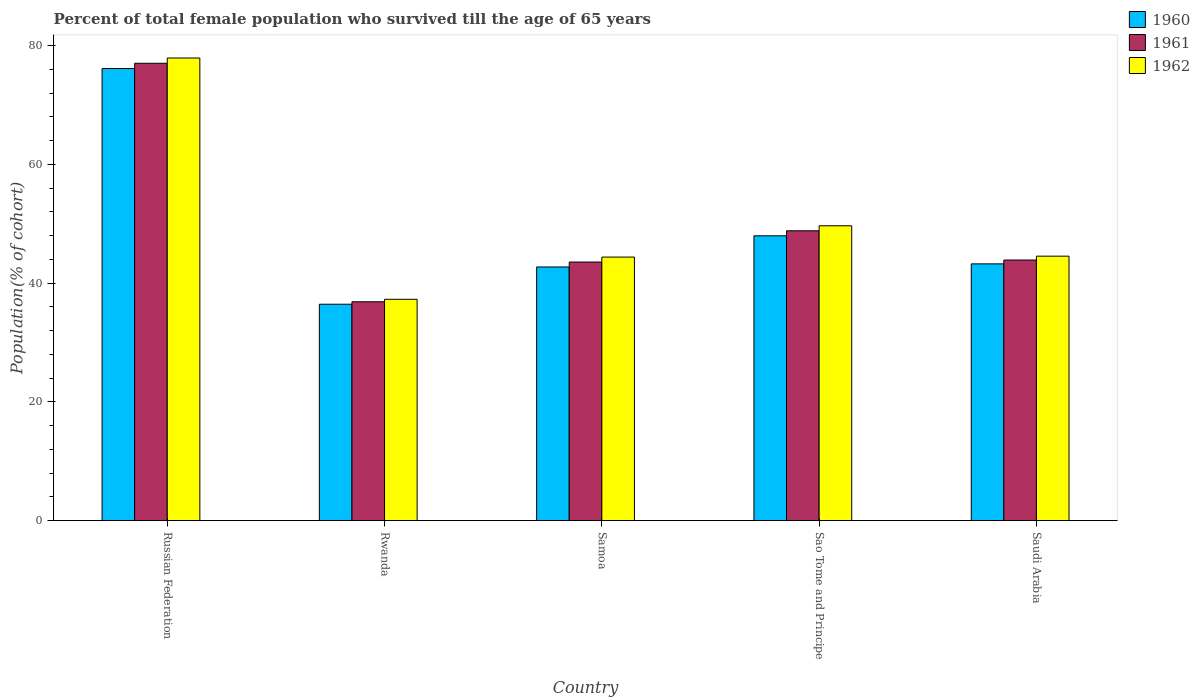Are the number of bars on each tick of the X-axis equal?
Make the answer very short. Yes. How many bars are there on the 4th tick from the right?
Offer a very short reply. 3. What is the label of the 5th group of bars from the left?
Make the answer very short. Saudi Arabia. What is the percentage of total female population who survived till the age of 65 years in 1961 in Russian Federation?
Your answer should be compact. 77.03. Across all countries, what is the maximum percentage of total female population who survived till the age of 65 years in 1961?
Provide a succinct answer. 77.03. Across all countries, what is the minimum percentage of total female population who survived till the age of 65 years in 1961?
Provide a succinct answer. 36.86. In which country was the percentage of total female population who survived till the age of 65 years in 1962 maximum?
Keep it short and to the point. Russian Federation. In which country was the percentage of total female population who survived till the age of 65 years in 1962 minimum?
Your answer should be compact. Rwanda. What is the total percentage of total female population who survived till the age of 65 years in 1962 in the graph?
Ensure brevity in your answer.  253.78. What is the difference between the percentage of total female population who survived till the age of 65 years in 1960 in Russian Federation and that in Rwanda?
Offer a very short reply. 39.7. What is the difference between the percentage of total female population who survived till the age of 65 years in 1962 in Saudi Arabia and the percentage of total female population who survived till the age of 65 years in 1960 in Russian Federation?
Offer a very short reply. -31.61. What is the average percentage of total female population who survived till the age of 65 years in 1962 per country?
Provide a short and direct response. 50.76. What is the difference between the percentage of total female population who survived till the age of 65 years of/in 1961 and percentage of total female population who survived till the age of 65 years of/in 1962 in Samoa?
Keep it short and to the point. -0.83. What is the ratio of the percentage of total female population who survived till the age of 65 years in 1960 in Russian Federation to that in Samoa?
Your response must be concise. 1.78. Is the percentage of total female population who survived till the age of 65 years in 1960 in Russian Federation less than that in Sao Tome and Principe?
Provide a succinct answer. No. Is the difference between the percentage of total female population who survived till the age of 65 years in 1961 in Russian Federation and Samoa greater than the difference between the percentage of total female population who survived till the age of 65 years in 1962 in Russian Federation and Samoa?
Make the answer very short. No. What is the difference between the highest and the second highest percentage of total female population who survived till the age of 65 years in 1960?
Offer a very short reply. -32.91. What is the difference between the highest and the lowest percentage of total female population who survived till the age of 65 years in 1961?
Make the answer very short. 40.18. In how many countries, is the percentage of total female population who survived till the age of 65 years in 1960 greater than the average percentage of total female population who survived till the age of 65 years in 1960 taken over all countries?
Ensure brevity in your answer.  1. What does the 1st bar from the left in Saudi Arabia represents?
Provide a short and direct response. 1960. Is it the case that in every country, the sum of the percentage of total female population who survived till the age of 65 years in 1961 and percentage of total female population who survived till the age of 65 years in 1962 is greater than the percentage of total female population who survived till the age of 65 years in 1960?
Offer a terse response. Yes. How many bars are there?
Keep it short and to the point. 15. Are all the bars in the graph horizontal?
Keep it short and to the point. No. How many countries are there in the graph?
Keep it short and to the point. 5. What is the difference between two consecutive major ticks on the Y-axis?
Give a very brief answer. 20. Are the values on the major ticks of Y-axis written in scientific E-notation?
Offer a very short reply. No. Does the graph contain any zero values?
Provide a succinct answer. No. Where does the legend appear in the graph?
Ensure brevity in your answer.  Top right. What is the title of the graph?
Provide a short and direct response. Percent of total female population who survived till the age of 65 years. Does "2000" appear as one of the legend labels in the graph?
Your response must be concise. No. What is the label or title of the X-axis?
Make the answer very short. Country. What is the label or title of the Y-axis?
Offer a terse response. Population(% of cohort). What is the Population(% of cohort) in 1960 in Russian Federation?
Make the answer very short. 76.15. What is the Population(% of cohort) in 1961 in Russian Federation?
Provide a short and direct response. 77.03. What is the Population(% of cohort) of 1962 in Russian Federation?
Ensure brevity in your answer.  77.92. What is the Population(% of cohort) in 1960 in Rwanda?
Your response must be concise. 36.44. What is the Population(% of cohort) in 1961 in Rwanda?
Your answer should be compact. 36.86. What is the Population(% of cohort) of 1962 in Rwanda?
Provide a short and direct response. 37.27. What is the Population(% of cohort) in 1960 in Samoa?
Make the answer very short. 42.72. What is the Population(% of cohort) of 1961 in Samoa?
Offer a terse response. 43.55. What is the Population(% of cohort) in 1962 in Samoa?
Give a very brief answer. 44.39. What is the Population(% of cohort) in 1960 in Sao Tome and Principe?
Your answer should be compact. 47.97. What is the Population(% of cohort) in 1961 in Sao Tome and Principe?
Your answer should be compact. 48.81. What is the Population(% of cohort) in 1962 in Sao Tome and Principe?
Make the answer very short. 49.66. What is the Population(% of cohort) in 1960 in Saudi Arabia?
Keep it short and to the point. 43.24. What is the Population(% of cohort) in 1961 in Saudi Arabia?
Your answer should be compact. 43.89. What is the Population(% of cohort) of 1962 in Saudi Arabia?
Provide a succinct answer. 44.54. Across all countries, what is the maximum Population(% of cohort) of 1960?
Ensure brevity in your answer.  76.15. Across all countries, what is the maximum Population(% of cohort) in 1961?
Your answer should be very brief. 77.03. Across all countries, what is the maximum Population(% of cohort) of 1962?
Make the answer very short. 77.92. Across all countries, what is the minimum Population(% of cohort) of 1960?
Offer a terse response. 36.44. Across all countries, what is the minimum Population(% of cohort) of 1961?
Provide a succinct answer. 36.86. Across all countries, what is the minimum Population(% of cohort) of 1962?
Ensure brevity in your answer.  37.27. What is the total Population(% of cohort) in 1960 in the graph?
Make the answer very short. 246.53. What is the total Population(% of cohort) in 1961 in the graph?
Ensure brevity in your answer.  250.15. What is the total Population(% of cohort) in 1962 in the graph?
Offer a terse response. 253.78. What is the difference between the Population(% of cohort) of 1960 in Russian Federation and that in Rwanda?
Ensure brevity in your answer.  39.7. What is the difference between the Population(% of cohort) in 1961 in Russian Federation and that in Rwanda?
Offer a very short reply. 40.18. What is the difference between the Population(% of cohort) of 1962 in Russian Federation and that in Rwanda?
Give a very brief answer. 40.65. What is the difference between the Population(% of cohort) in 1960 in Russian Federation and that in Samoa?
Your response must be concise. 33.43. What is the difference between the Population(% of cohort) in 1961 in Russian Federation and that in Samoa?
Your answer should be very brief. 33.48. What is the difference between the Population(% of cohort) of 1962 in Russian Federation and that in Samoa?
Your answer should be compact. 33.54. What is the difference between the Population(% of cohort) in 1960 in Russian Federation and that in Sao Tome and Principe?
Offer a terse response. 28.18. What is the difference between the Population(% of cohort) in 1961 in Russian Federation and that in Sao Tome and Principe?
Provide a succinct answer. 28.22. What is the difference between the Population(% of cohort) in 1962 in Russian Federation and that in Sao Tome and Principe?
Make the answer very short. 28.26. What is the difference between the Population(% of cohort) of 1960 in Russian Federation and that in Saudi Arabia?
Offer a very short reply. 32.91. What is the difference between the Population(% of cohort) of 1961 in Russian Federation and that in Saudi Arabia?
Provide a short and direct response. 33.14. What is the difference between the Population(% of cohort) of 1962 in Russian Federation and that in Saudi Arabia?
Give a very brief answer. 33.38. What is the difference between the Population(% of cohort) of 1960 in Rwanda and that in Samoa?
Ensure brevity in your answer.  -6.28. What is the difference between the Population(% of cohort) in 1961 in Rwanda and that in Samoa?
Your response must be concise. -6.69. What is the difference between the Population(% of cohort) of 1962 in Rwanda and that in Samoa?
Your answer should be very brief. -7.11. What is the difference between the Population(% of cohort) of 1960 in Rwanda and that in Sao Tome and Principe?
Give a very brief answer. -11.53. What is the difference between the Population(% of cohort) in 1961 in Rwanda and that in Sao Tome and Principe?
Give a very brief answer. -11.96. What is the difference between the Population(% of cohort) in 1962 in Rwanda and that in Sao Tome and Principe?
Keep it short and to the point. -12.38. What is the difference between the Population(% of cohort) in 1960 in Rwanda and that in Saudi Arabia?
Ensure brevity in your answer.  -6.8. What is the difference between the Population(% of cohort) of 1961 in Rwanda and that in Saudi Arabia?
Ensure brevity in your answer.  -7.03. What is the difference between the Population(% of cohort) in 1962 in Rwanda and that in Saudi Arabia?
Give a very brief answer. -7.27. What is the difference between the Population(% of cohort) in 1960 in Samoa and that in Sao Tome and Principe?
Give a very brief answer. -5.25. What is the difference between the Population(% of cohort) in 1961 in Samoa and that in Sao Tome and Principe?
Your answer should be compact. -5.26. What is the difference between the Population(% of cohort) in 1962 in Samoa and that in Sao Tome and Principe?
Your answer should be very brief. -5.27. What is the difference between the Population(% of cohort) of 1960 in Samoa and that in Saudi Arabia?
Keep it short and to the point. -0.52. What is the difference between the Population(% of cohort) of 1961 in Samoa and that in Saudi Arabia?
Give a very brief answer. -0.34. What is the difference between the Population(% of cohort) of 1962 in Samoa and that in Saudi Arabia?
Offer a very short reply. -0.16. What is the difference between the Population(% of cohort) of 1960 in Sao Tome and Principe and that in Saudi Arabia?
Your answer should be compact. 4.73. What is the difference between the Population(% of cohort) in 1961 in Sao Tome and Principe and that in Saudi Arabia?
Offer a terse response. 4.92. What is the difference between the Population(% of cohort) of 1962 in Sao Tome and Principe and that in Saudi Arabia?
Your response must be concise. 5.12. What is the difference between the Population(% of cohort) of 1960 in Russian Federation and the Population(% of cohort) of 1961 in Rwanda?
Your answer should be compact. 39.29. What is the difference between the Population(% of cohort) in 1960 in Russian Federation and the Population(% of cohort) in 1962 in Rwanda?
Make the answer very short. 38.87. What is the difference between the Population(% of cohort) in 1961 in Russian Federation and the Population(% of cohort) in 1962 in Rwanda?
Ensure brevity in your answer.  39.76. What is the difference between the Population(% of cohort) in 1960 in Russian Federation and the Population(% of cohort) in 1961 in Samoa?
Offer a terse response. 32.6. What is the difference between the Population(% of cohort) in 1960 in Russian Federation and the Population(% of cohort) in 1962 in Samoa?
Provide a short and direct response. 31.76. What is the difference between the Population(% of cohort) of 1961 in Russian Federation and the Population(% of cohort) of 1962 in Samoa?
Your answer should be very brief. 32.65. What is the difference between the Population(% of cohort) of 1960 in Russian Federation and the Population(% of cohort) of 1961 in Sao Tome and Principe?
Give a very brief answer. 27.33. What is the difference between the Population(% of cohort) of 1960 in Russian Federation and the Population(% of cohort) of 1962 in Sao Tome and Principe?
Your response must be concise. 26.49. What is the difference between the Population(% of cohort) of 1961 in Russian Federation and the Population(% of cohort) of 1962 in Sao Tome and Principe?
Keep it short and to the point. 27.38. What is the difference between the Population(% of cohort) of 1960 in Russian Federation and the Population(% of cohort) of 1961 in Saudi Arabia?
Your answer should be very brief. 32.26. What is the difference between the Population(% of cohort) in 1960 in Russian Federation and the Population(% of cohort) in 1962 in Saudi Arabia?
Your response must be concise. 31.61. What is the difference between the Population(% of cohort) of 1961 in Russian Federation and the Population(% of cohort) of 1962 in Saudi Arabia?
Provide a succinct answer. 32.49. What is the difference between the Population(% of cohort) in 1960 in Rwanda and the Population(% of cohort) in 1961 in Samoa?
Provide a short and direct response. -7.11. What is the difference between the Population(% of cohort) of 1960 in Rwanda and the Population(% of cohort) of 1962 in Samoa?
Offer a very short reply. -7.94. What is the difference between the Population(% of cohort) in 1961 in Rwanda and the Population(% of cohort) in 1962 in Samoa?
Your response must be concise. -7.53. What is the difference between the Population(% of cohort) in 1960 in Rwanda and the Population(% of cohort) in 1961 in Sao Tome and Principe?
Ensure brevity in your answer.  -12.37. What is the difference between the Population(% of cohort) of 1960 in Rwanda and the Population(% of cohort) of 1962 in Sao Tome and Principe?
Your answer should be compact. -13.21. What is the difference between the Population(% of cohort) in 1961 in Rwanda and the Population(% of cohort) in 1962 in Sao Tome and Principe?
Ensure brevity in your answer.  -12.8. What is the difference between the Population(% of cohort) of 1960 in Rwanda and the Population(% of cohort) of 1961 in Saudi Arabia?
Your answer should be compact. -7.45. What is the difference between the Population(% of cohort) of 1960 in Rwanda and the Population(% of cohort) of 1962 in Saudi Arabia?
Your response must be concise. -8.1. What is the difference between the Population(% of cohort) in 1961 in Rwanda and the Population(% of cohort) in 1962 in Saudi Arabia?
Ensure brevity in your answer.  -7.68. What is the difference between the Population(% of cohort) in 1960 in Samoa and the Population(% of cohort) in 1961 in Sao Tome and Principe?
Keep it short and to the point. -6.09. What is the difference between the Population(% of cohort) in 1960 in Samoa and the Population(% of cohort) in 1962 in Sao Tome and Principe?
Offer a terse response. -6.94. What is the difference between the Population(% of cohort) in 1961 in Samoa and the Population(% of cohort) in 1962 in Sao Tome and Principe?
Give a very brief answer. -6.1. What is the difference between the Population(% of cohort) of 1960 in Samoa and the Population(% of cohort) of 1961 in Saudi Arabia?
Your answer should be very brief. -1.17. What is the difference between the Population(% of cohort) in 1960 in Samoa and the Population(% of cohort) in 1962 in Saudi Arabia?
Give a very brief answer. -1.82. What is the difference between the Population(% of cohort) in 1961 in Samoa and the Population(% of cohort) in 1962 in Saudi Arabia?
Give a very brief answer. -0.99. What is the difference between the Population(% of cohort) of 1960 in Sao Tome and Principe and the Population(% of cohort) of 1961 in Saudi Arabia?
Your answer should be very brief. 4.08. What is the difference between the Population(% of cohort) of 1960 in Sao Tome and Principe and the Population(% of cohort) of 1962 in Saudi Arabia?
Your answer should be very brief. 3.43. What is the difference between the Population(% of cohort) in 1961 in Sao Tome and Principe and the Population(% of cohort) in 1962 in Saudi Arabia?
Provide a short and direct response. 4.27. What is the average Population(% of cohort) of 1960 per country?
Your answer should be very brief. 49.31. What is the average Population(% of cohort) in 1961 per country?
Offer a terse response. 50.03. What is the average Population(% of cohort) of 1962 per country?
Your answer should be very brief. 50.76. What is the difference between the Population(% of cohort) of 1960 and Population(% of cohort) of 1961 in Russian Federation?
Provide a short and direct response. -0.89. What is the difference between the Population(% of cohort) of 1960 and Population(% of cohort) of 1962 in Russian Federation?
Make the answer very short. -1.77. What is the difference between the Population(% of cohort) of 1961 and Population(% of cohort) of 1962 in Russian Federation?
Make the answer very short. -0.89. What is the difference between the Population(% of cohort) of 1960 and Population(% of cohort) of 1961 in Rwanda?
Provide a succinct answer. -0.41. What is the difference between the Population(% of cohort) of 1960 and Population(% of cohort) of 1962 in Rwanda?
Give a very brief answer. -0.83. What is the difference between the Population(% of cohort) in 1961 and Population(% of cohort) in 1962 in Rwanda?
Your response must be concise. -0.41. What is the difference between the Population(% of cohort) of 1960 and Population(% of cohort) of 1961 in Samoa?
Ensure brevity in your answer.  -0.83. What is the difference between the Population(% of cohort) in 1960 and Population(% of cohort) in 1962 in Samoa?
Provide a short and direct response. -1.66. What is the difference between the Population(% of cohort) of 1961 and Population(% of cohort) of 1962 in Samoa?
Offer a very short reply. -0.83. What is the difference between the Population(% of cohort) in 1960 and Population(% of cohort) in 1961 in Sao Tome and Principe?
Keep it short and to the point. -0.84. What is the difference between the Population(% of cohort) of 1960 and Population(% of cohort) of 1962 in Sao Tome and Principe?
Ensure brevity in your answer.  -1.69. What is the difference between the Population(% of cohort) in 1961 and Population(% of cohort) in 1962 in Sao Tome and Principe?
Offer a very short reply. -0.84. What is the difference between the Population(% of cohort) of 1960 and Population(% of cohort) of 1961 in Saudi Arabia?
Offer a terse response. -0.65. What is the difference between the Population(% of cohort) in 1960 and Population(% of cohort) in 1962 in Saudi Arabia?
Your answer should be very brief. -1.3. What is the difference between the Population(% of cohort) of 1961 and Population(% of cohort) of 1962 in Saudi Arabia?
Give a very brief answer. -0.65. What is the ratio of the Population(% of cohort) of 1960 in Russian Federation to that in Rwanda?
Keep it short and to the point. 2.09. What is the ratio of the Population(% of cohort) of 1961 in Russian Federation to that in Rwanda?
Provide a succinct answer. 2.09. What is the ratio of the Population(% of cohort) of 1962 in Russian Federation to that in Rwanda?
Make the answer very short. 2.09. What is the ratio of the Population(% of cohort) of 1960 in Russian Federation to that in Samoa?
Offer a very short reply. 1.78. What is the ratio of the Population(% of cohort) in 1961 in Russian Federation to that in Samoa?
Provide a short and direct response. 1.77. What is the ratio of the Population(% of cohort) of 1962 in Russian Federation to that in Samoa?
Your response must be concise. 1.76. What is the ratio of the Population(% of cohort) in 1960 in Russian Federation to that in Sao Tome and Principe?
Your response must be concise. 1.59. What is the ratio of the Population(% of cohort) in 1961 in Russian Federation to that in Sao Tome and Principe?
Make the answer very short. 1.58. What is the ratio of the Population(% of cohort) in 1962 in Russian Federation to that in Sao Tome and Principe?
Your response must be concise. 1.57. What is the ratio of the Population(% of cohort) of 1960 in Russian Federation to that in Saudi Arabia?
Offer a terse response. 1.76. What is the ratio of the Population(% of cohort) in 1961 in Russian Federation to that in Saudi Arabia?
Provide a short and direct response. 1.76. What is the ratio of the Population(% of cohort) in 1962 in Russian Federation to that in Saudi Arabia?
Provide a succinct answer. 1.75. What is the ratio of the Population(% of cohort) of 1960 in Rwanda to that in Samoa?
Your answer should be compact. 0.85. What is the ratio of the Population(% of cohort) in 1961 in Rwanda to that in Samoa?
Offer a terse response. 0.85. What is the ratio of the Population(% of cohort) of 1962 in Rwanda to that in Samoa?
Your answer should be compact. 0.84. What is the ratio of the Population(% of cohort) in 1960 in Rwanda to that in Sao Tome and Principe?
Your answer should be compact. 0.76. What is the ratio of the Population(% of cohort) in 1961 in Rwanda to that in Sao Tome and Principe?
Make the answer very short. 0.76. What is the ratio of the Population(% of cohort) in 1962 in Rwanda to that in Sao Tome and Principe?
Provide a succinct answer. 0.75. What is the ratio of the Population(% of cohort) of 1960 in Rwanda to that in Saudi Arabia?
Give a very brief answer. 0.84. What is the ratio of the Population(% of cohort) of 1961 in Rwanda to that in Saudi Arabia?
Your answer should be very brief. 0.84. What is the ratio of the Population(% of cohort) of 1962 in Rwanda to that in Saudi Arabia?
Keep it short and to the point. 0.84. What is the ratio of the Population(% of cohort) in 1960 in Samoa to that in Sao Tome and Principe?
Provide a short and direct response. 0.89. What is the ratio of the Population(% of cohort) in 1961 in Samoa to that in Sao Tome and Principe?
Ensure brevity in your answer.  0.89. What is the ratio of the Population(% of cohort) of 1962 in Samoa to that in Sao Tome and Principe?
Make the answer very short. 0.89. What is the ratio of the Population(% of cohort) in 1960 in Samoa to that in Saudi Arabia?
Keep it short and to the point. 0.99. What is the ratio of the Population(% of cohort) in 1960 in Sao Tome and Principe to that in Saudi Arabia?
Your response must be concise. 1.11. What is the ratio of the Population(% of cohort) of 1961 in Sao Tome and Principe to that in Saudi Arabia?
Give a very brief answer. 1.11. What is the ratio of the Population(% of cohort) in 1962 in Sao Tome and Principe to that in Saudi Arabia?
Your response must be concise. 1.11. What is the difference between the highest and the second highest Population(% of cohort) of 1960?
Give a very brief answer. 28.18. What is the difference between the highest and the second highest Population(% of cohort) in 1961?
Provide a succinct answer. 28.22. What is the difference between the highest and the second highest Population(% of cohort) in 1962?
Provide a succinct answer. 28.26. What is the difference between the highest and the lowest Population(% of cohort) in 1960?
Ensure brevity in your answer.  39.7. What is the difference between the highest and the lowest Population(% of cohort) of 1961?
Offer a very short reply. 40.18. What is the difference between the highest and the lowest Population(% of cohort) in 1962?
Ensure brevity in your answer.  40.65. 